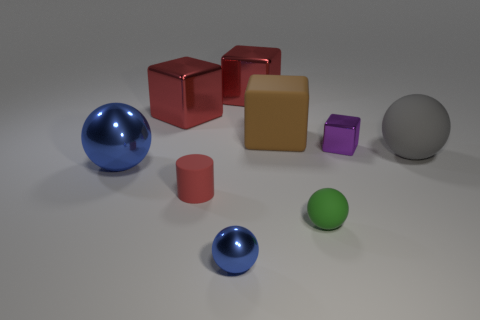Subtract all spheres. How many objects are left? 5 Subtract 2 blue spheres. How many objects are left? 7 Subtract all big shiny blocks. Subtract all tiny rubber objects. How many objects are left? 5 Add 9 small green balls. How many small green balls are left? 10 Add 3 rubber spheres. How many rubber spheres exist? 5 